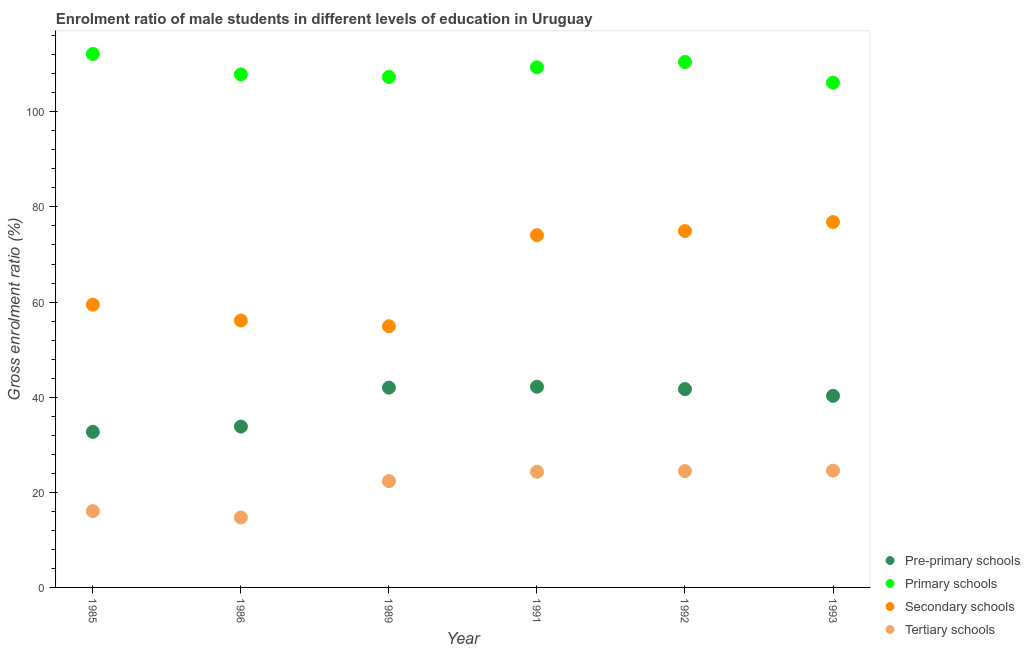What is the gross enrolment ratio(female) in secondary schools in 1991?
Provide a short and direct response. 74.06. Across all years, what is the maximum gross enrolment ratio(female) in pre-primary schools?
Keep it short and to the point. 42.2. Across all years, what is the minimum gross enrolment ratio(female) in tertiary schools?
Your answer should be very brief. 14.7. In which year was the gross enrolment ratio(female) in tertiary schools maximum?
Offer a very short reply. 1993. In which year was the gross enrolment ratio(female) in primary schools minimum?
Offer a very short reply. 1993. What is the total gross enrolment ratio(female) in pre-primary schools in the graph?
Ensure brevity in your answer.  232.72. What is the difference between the gross enrolment ratio(female) in secondary schools in 1989 and that in 1991?
Provide a short and direct response. -19.15. What is the difference between the gross enrolment ratio(female) in tertiary schools in 1993 and the gross enrolment ratio(female) in pre-primary schools in 1991?
Keep it short and to the point. -17.64. What is the average gross enrolment ratio(female) in primary schools per year?
Provide a succinct answer. 108.88. In the year 1992, what is the difference between the gross enrolment ratio(female) in pre-primary schools and gross enrolment ratio(female) in primary schools?
Provide a succinct answer. -68.77. What is the ratio of the gross enrolment ratio(female) in primary schools in 1985 to that in 1992?
Your response must be concise. 1.02. Is the gross enrolment ratio(female) in secondary schools in 1991 less than that in 1993?
Your answer should be very brief. Yes. What is the difference between the highest and the second highest gross enrolment ratio(female) in tertiary schools?
Make the answer very short. 0.1. What is the difference between the highest and the lowest gross enrolment ratio(female) in secondary schools?
Give a very brief answer. 21.92. In how many years, is the gross enrolment ratio(female) in secondary schools greater than the average gross enrolment ratio(female) in secondary schools taken over all years?
Offer a very short reply. 3. Is the sum of the gross enrolment ratio(female) in secondary schools in 1986 and 1991 greater than the maximum gross enrolment ratio(female) in tertiary schools across all years?
Your answer should be compact. Yes. Is the gross enrolment ratio(female) in pre-primary schools strictly greater than the gross enrolment ratio(female) in primary schools over the years?
Ensure brevity in your answer.  No. Is the gross enrolment ratio(female) in tertiary schools strictly less than the gross enrolment ratio(female) in primary schools over the years?
Your answer should be compact. Yes. How many dotlines are there?
Provide a short and direct response. 4. How many years are there in the graph?
Keep it short and to the point. 6. What is the difference between two consecutive major ticks on the Y-axis?
Provide a short and direct response. 20. Does the graph contain any zero values?
Keep it short and to the point. No. Where does the legend appear in the graph?
Your answer should be very brief. Bottom right. How many legend labels are there?
Your answer should be very brief. 4. What is the title of the graph?
Offer a terse response. Enrolment ratio of male students in different levels of education in Uruguay. Does "UNTA" appear as one of the legend labels in the graph?
Provide a succinct answer. No. What is the Gross enrolment ratio (%) in Pre-primary schools in 1985?
Offer a terse response. 32.71. What is the Gross enrolment ratio (%) of Primary schools in 1985?
Offer a very short reply. 112.15. What is the Gross enrolment ratio (%) in Secondary schools in 1985?
Keep it short and to the point. 59.44. What is the Gross enrolment ratio (%) of Tertiary schools in 1985?
Ensure brevity in your answer.  16.04. What is the Gross enrolment ratio (%) in Pre-primary schools in 1986?
Your answer should be compact. 33.83. What is the Gross enrolment ratio (%) of Primary schools in 1986?
Your response must be concise. 107.86. What is the Gross enrolment ratio (%) in Secondary schools in 1986?
Offer a very short reply. 56.11. What is the Gross enrolment ratio (%) of Tertiary schools in 1986?
Your response must be concise. 14.7. What is the Gross enrolment ratio (%) of Pre-primary schools in 1989?
Ensure brevity in your answer.  42.01. What is the Gross enrolment ratio (%) of Primary schools in 1989?
Give a very brief answer. 107.32. What is the Gross enrolment ratio (%) of Secondary schools in 1989?
Ensure brevity in your answer.  54.91. What is the Gross enrolment ratio (%) in Tertiary schools in 1989?
Give a very brief answer. 22.36. What is the Gross enrolment ratio (%) of Pre-primary schools in 1991?
Offer a terse response. 42.2. What is the Gross enrolment ratio (%) of Primary schools in 1991?
Keep it short and to the point. 109.35. What is the Gross enrolment ratio (%) in Secondary schools in 1991?
Offer a very short reply. 74.06. What is the Gross enrolment ratio (%) of Tertiary schools in 1991?
Provide a short and direct response. 24.33. What is the Gross enrolment ratio (%) of Pre-primary schools in 1992?
Provide a succinct answer. 41.7. What is the Gross enrolment ratio (%) of Primary schools in 1992?
Provide a succinct answer. 110.47. What is the Gross enrolment ratio (%) of Secondary schools in 1992?
Keep it short and to the point. 74.94. What is the Gross enrolment ratio (%) of Tertiary schools in 1992?
Give a very brief answer. 24.45. What is the Gross enrolment ratio (%) in Pre-primary schools in 1993?
Ensure brevity in your answer.  40.28. What is the Gross enrolment ratio (%) of Primary schools in 1993?
Give a very brief answer. 106.11. What is the Gross enrolment ratio (%) of Secondary schools in 1993?
Your answer should be compact. 76.83. What is the Gross enrolment ratio (%) in Tertiary schools in 1993?
Your answer should be compact. 24.55. Across all years, what is the maximum Gross enrolment ratio (%) in Pre-primary schools?
Your answer should be compact. 42.2. Across all years, what is the maximum Gross enrolment ratio (%) in Primary schools?
Offer a very short reply. 112.15. Across all years, what is the maximum Gross enrolment ratio (%) in Secondary schools?
Keep it short and to the point. 76.83. Across all years, what is the maximum Gross enrolment ratio (%) of Tertiary schools?
Offer a terse response. 24.55. Across all years, what is the minimum Gross enrolment ratio (%) of Pre-primary schools?
Give a very brief answer. 32.71. Across all years, what is the minimum Gross enrolment ratio (%) of Primary schools?
Ensure brevity in your answer.  106.11. Across all years, what is the minimum Gross enrolment ratio (%) in Secondary schools?
Offer a terse response. 54.91. Across all years, what is the minimum Gross enrolment ratio (%) in Tertiary schools?
Offer a very short reply. 14.7. What is the total Gross enrolment ratio (%) in Pre-primary schools in the graph?
Your answer should be very brief. 232.72. What is the total Gross enrolment ratio (%) of Primary schools in the graph?
Your response must be concise. 653.27. What is the total Gross enrolment ratio (%) of Secondary schools in the graph?
Make the answer very short. 396.29. What is the total Gross enrolment ratio (%) of Tertiary schools in the graph?
Make the answer very short. 126.43. What is the difference between the Gross enrolment ratio (%) in Pre-primary schools in 1985 and that in 1986?
Offer a terse response. -1.12. What is the difference between the Gross enrolment ratio (%) of Primary schools in 1985 and that in 1986?
Provide a short and direct response. 4.29. What is the difference between the Gross enrolment ratio (%) in Secondary schools in 1985 and that in 1986?
Ensure brevity in your answer.  3.33. What is the difference between the Gross enrolment ratio (%) in Tertiary schools in 1985 and that in 1986?
Provide a succinct answer. 1.34. What is the difference between the Gross enrolment ratio (%) of Pre-primary schools in 1985 and that in 1989?
Ensure brevity in your answer.  -9.3. What is the difference between the Gross enrolment ratio (%) of Primary schools in 1985 and that in 1989?
Your answer should be compact. 4.83. What is the difference between the Gross enrolment ratio (%) in Secondary schools in 1985 and that in 1989?
Offer a terse response. 4.53. What is the difference between the Gross enrolment ratio (%) of Tertiary schools in 1985 and that in 1989?
Ensure brevity in your answer.  -6.32. What is the difference between the Gross enrolment ratio (%) of Pre-primary schools in 1985 and that in 1991?
Your response must be concise. -9.49. What is the difference between the Gross enrolment ratio (%) in Primary schools in 1985 and that in 1991?
Your answer should be compact. 2.81. What is the difference between the Gross enrolment ratio (%) of Secondary schools in 1985 and that in 1991?
Ensure brevity in your answer.  -14.62. What is the difference between the Gross enrolment ratio (%) of Tertiary schools in 1985 and that in 1991?
Your response must be concise. -8.29. What is the difference between the Gross enrolment ratio (%) in Pre-primary schools in 1985 and that in 1992?
Ensure brevity in your answer.  -8.99. What is the difference between the Gross enrolment ratio (%) in Primary schools in 1985 and that in 1992?
Keep it short and to the point. 1.69. What is the difference between the Gross enrolment ratio (%) of Secondary schools in 1985 and that in 1992?
Your answer should be very brief. -15.49. What is the difference between the Gross enrolment ratio (%) of Tertiary schools in 1985 and that in 1992?
Ensure brevity in your answer.  -8.41. What is the difference between the Gross enrolment ratio (%) of Pre-primary schools in 1985 and that in 1993?
Make the answer very short. -7.57. What is the difference between the Gross enrolment ratio (%) in Primary schools in 1985 and that in 1993?
Offer a terse response. 6.04. What is the difference between the Gross enrolment ratio (%) of Secondary schools in 1985 and that in 1993?
Provide a succinct answer. -17.38. What is the difference between the Gross enrolment ratio (%) of Tertiary schools in 1985 and that in 1993?
Ensure brevity in your answer.  -8.51. What is the difference between the Gross enrolment ratio (%) in Pre-primary schools in 1986 and that in 1989?
Your answer should be compact. -8.18. What is the difference between the Gross enrolment ratio (%) of Primary schools in 1986 and that in 1989?
Offer a terse response. 0.54. What is the difference between the Gross enrolment ratio (%) of Secondary schools in 1986 and that in 1989?
Offer a very short reply. 1.2. What is the difference between the Gross enrolment ratio (%) of Tertiary schools in 1986 and that in 1989?
Your answer should be very brief. -7.66. What is the difference between the Gross enrolment ratio (%) of Pre-primary schools in 1986 and that in 1991?
Make the answer very short. -8.37. What is the difference between the Gross enrolment ratio (%) in Primary schools in 1986 and that in 1991?
Offer a very short reply. -1.48. What is the difference between the Gross enrolment ratio (%) of Secondary schools in 1986 and that in 1991?
Give a very brief answer. -17.95. What is the difference between the Gross enrolment ratio (%) in Tertiary schools in 1986 and that in 1991?
Your response must be concise. -9.63. What is the difference between the Gross enrolment ratio (%) of Pre-primary schools in 1986 and that in 1992?
Make the answer very short. -7.88. What is the difference between the Gross enrolment ratio (%) in Primary schools in 1986 and that in 1992?
Your response must be concise. -2.61. What is the difference between the Gross enrolment ratio (%) of Secondary schools in 1986 and that in 1992?
Provide a succinct answer. -18.82. What is the difference between the Gross enrolment ratio (%) in Tertiary schools in 1986 and that in 1992?
Your response must be concise. -9.76. What is the difference between the Gross enrolment ratio (%) of Pre-primary schools in 1986 and that in 1993?
Keep it short and to the point. -6.45. What is the difference between the Gross enrolment ratio (%) in Primary schools in 1986 and that in 1993?
Your answer should be very brief. 1.75. What is the difference between the Gross enrolment ratio (%) in Secondary schools in 1986 and that in 1993?
Offer a very short reply. -20.71. What is the difference between the Gross enrolment ratio (%) of Tertiary schools in 1986 and that in 1993?
Your answer should be very brief. -9.85. What is the difference between the Gross enrolment ratio (%) of Pre-primary schools in 1989 and that in 1991?
Your response must be concise. -0.19. What is the difference between the Gross enrolment ratio (%) in Primary schools in 1989 and that in 1991?
Your answer should be very brief. -2.02. What is the difference between the Gross enrolment ratio (%) in Secondary schools in 1989 and that in 1991?
Keep it short and to the point. -19.15. What is the difference between the Gross enrolment ratio (%) of Tertiary schools in 1989 and that in 1991?
Offer a terse response. -1.97. What is the difference between the Gross enrolment ratio (%) in Pre-primary schools in 1989 and that in 1992?
Your response must be concise. 0.31. What is the difference between the Gross enrolment ratio (%) in Primary schools in 1989 and that in 1992?
Ensure brevity in your answer.  -3.14. What is the difference between the Gross enrolment ratio (%) of Secondary schools in 1989 and that in 1992?
Provide a short and direct response. -20.02. What is the difference between the Gross enrolment ratio (%) in Tertiary schools in 1989 and that in 1992?
Give a very brief answer. -2.1. What is the difference between the Gross enrolment ratio (%) of Pre-primary schools in 1989 and that in 1993?
Provide a succinct answer. 1.73. What is the difference between the Gross enrolment ratio (%) in Primary schools in 1989 and that in 1993?
Your response must be concise. 1.21. What is the difference between the Gross enrolment ratio (%) in Secondary schools in 1989 and that in 1993?
Ensure brevity in your answer.  -21.92. What is the difference between the Gross enrolment ratio (%) of Tertiary schools in 1989 and that in 1993?
Offer a very short reply. -2.2. What is the difference between the Gross enrolment ratio (%) of Pre-primary schools in 1991 and that in 1992?
Provide a succinct answer. 0.49. What is the difference between the Gross enrolment ratio (%) in Primary schools in 1991 and that in 1992?
Offer a terse response. -1.12. What is the difference between the Gross enrolment ratio (%) in Secondary schools in 1991 and that in 1992?
Make the answer very short. -0.88. What is the difference between the Gross enrolment ratio (%) in Tertiary schools in 1991 and that in 1992?
Offer a very short reply. -0.13. What is the difference between the Gross enrolment ratio (%) of Pre-primary schools in 1991 and that in 1993?
Give a very brief answer. 1.92. What is the difference between the Gross enrolment ratio (%) in Primary schools in 1991 and that in 1993?
Provide a short and direct response. 3.23. What is the difference between the Gross enrolment ratio (%) of Secondary schools in 1991 and that in 1993?
Ensure brevity in your answer.  -2.77. What is the difference between the Gross enrolment ratio (%) of Tertiary schools in 1991 and that in 1993?
Your answer should be compact. -0.22. What is the difference between the Gross enrolment ratio (%) in Pre-primary schools in 1992 and that in 1993?
Offer a terse response. 1.42. What is the difference between the Gross enrolment ratio (%) in Primary schools in 1992 and that in 1993?
Give a very brief answer. 4.36. What is the difference between the Gross enrolment ratio (%) of Secondary schools in 1992 and that in 1993?
Keep it short and to the point. -1.89. What is the difference between the Gross enrolment ratio (%) of Tertiary schools in 1992 and that in 1993?
Offer a very short reply. -0.1. What is the difference between the Gross enrolment ratio (%) of Pre-primary schools in 1985 and the Gross enrolment ratio (%) of Primary schools in 1986?
Your response must be concise. -75.15. What is the difference between the Gross enrolment ratio (%) in Pre-primary schools in 1985 and the Gross enrolment ratio (%) in Secondary schools in 1986?
Offer a terse response. -23.4. What is the difference between the Gross enrolment ratio (%) in Pre-primary schools in 1985 and the Gross enrolment ratio (%) in Tertiary schools in 1986?
Offer a terse response. 18.01. What is the difference between the Gross enrolment ratio (%) of Primary schools in 1985 and the Gross enrolment ratio (%) of Secondary schools in 1986?
Your answer should be compact. 56.04. What is the difference between the Gross enrolment ratio (%) in Primary schools in 1985 and the Gross enrolment ratio (%) in Tertiary schools in 1986?
Offer a very short reply. 97.45. What is the difference between the Gross enrolment ratio (%) in Secondary schools in 1985 and the Gross enrolment ratio (%) in Tertiary schools in 1986?
Your response must be concise. 44.74. What is the difference between the Gross enrolment ratio (%) in Pre-primary schools in 1985 and the Gross enrolment ratio (%) in Primary schools in 1989?
Your answer should be very brief. -74.61. What is the difference between the Gross enrolment ratio (%) of Pre-primary schools in 1985 and the Gross enrolment ratio (%) of Secondary schools in 1989?
Ensure brevity in your answer.  -22.2. What is the difference between the Gross enrolment ratio (%) of Pre-primary schools in 1985 and the Gross enrolment ratio (%) of Tertiary schools in 1989?
Your answer should be very brief. 10.35. What is the difference between the Gross enrolment ratio (%) in Primary schools in 1985 and the Gross enrolment ratio (%) in Secondary schools in 1989?
Keep it short and to the point. 57.24. What is the difference between the Gross enrolment ratio (%) of Primary schools in 1985 and the Gross enrolment ratio (%) of Tertiary schools in 1989?
Provide a succinct answer. 89.8. What is the difference between the Gross enrolment ratio (%) of Secondary schools in 1985 and the Gross enrolment ratio (%) of Tertiary schools in 1989?
Provide a succinct answer. 37.09. What is the difference between the Gross enrolment ratio (%) of Pre-primary schools in 1985 and the Gross enrolment ratio (%) of Primary schools in 1991?
Make the answer very short. -76.64. What is the difference between the Gross enrolment ratio (%) in Pre-primary schools in 1985 and the Gross enrolment ratio (%) in Secondary schools in 1991?
Your response must be concise. -41.35. What is the difference between the Gross enrolment ratio (%) in Pre-primary schools in 1985 and the Gross enrolment ratio (%) in Tertiary schools in 1991?
Offer a terse response. 8.38. What is the difference between the Gross enrolment ratio (%) of Primary schools in 1985 and the Gross enrolment ratio (%) of Secondary schools in 1991?
Give a very brief answer. 38.09. What is the difference between the Gross enrolment ratio (%) of Primary schools in 1985 and the Gross enrolment ratio (%) of Tertiary schools in 1991?
Offer a terse response. 87.82. What is the difference between the Gross enrolment ratio (%) in Secondary schools in 1985 and the Gross enrolment ratio (%) in Tertiary schools in 1991?
Make the answer very short. 35.11. What is the difference between the Gross enrolment ratio (%) of Pre-primary schools in 1985 and the Gross enrolment ratio (%) of Primary schools in 1992?
Keep it short and to the point. -77.76. What is the difference between the Gross enrolment ratio (%) in Pre-primary schools in 1985 and the Gross enrolment ratio (%) in Secondary schools in 1992?
Offer a terse response. -42.23. What is the difference between the Gross enrolment ratio (%) of Pre-primary schools in 1985 and the Gross enrolment ratio (%) of Tertiary schools in 1992?
Your answer should be compact. 8.25. What is the difference between the Gross enrolment ratio (%) of Primary schools in 1985 and the Gross enrolment ratio (%) of Secondary schools in 1992?
Provide a succinct answer. 37.22. What is the difference between the Gross enrolment ratio (%) of Primary schools in 1985 and the Gross enrolment ratio (%) of Tertiary schools in 1992?
Give a very brief answer. 87.7. What is the difference between the Gross enrolment ratio (%) in Secondary schools in 1985 and the Gross enrolment ratio (%) in Tertiary schools in 1992?
Your response must be concise. 34.99. What is the difference between the Gross enrolment ratio (%) in Pre-primary schools in 1985 and the Gross enrolment ratio (%) in Primary schools in 1993?
Make the answer very short. -73.4. What is the difference between the Gross enrolment ratio (%) of Pre-primary schools in 1985 and the Gross enrolment ratio (%) of Secondary schools in 1993?
Make the answer very short. -44.12. What is the difference between the Gross enrolment ratio (%) in Pre-primary schools in 1985 and the Gross enrolment ratio (%) in Tertiary schools in 1993?
Provide a short and direct response. 8.16. What is the difference between the Gross enrolment ratio (%) in Primary schools in 1985 and the Gross enrolment ratio (%) in Secondary schools in 1993?
Make the answer very short. 35.33. What is the difference between the Gross enrolment ratio (%) in Primary schools in 1985 and the Gross enrolment ratio (%) in Tertiary schools in 1993?
Ensure brevity in your answer.  87.6. What is the difference between the Gross enrolment ratio (%) of Secondary schools in 1985 and the Gross enrolment ratio (%) of Tertiary schools in 1993?
Give a very brief answer. 34.89. What is the difference between the Gross enrolment ratio (%) in Pre-primary schools in 1986 and the Gross enrolment ratio (%) in Primary schools in 1989?
Keep it short and to the point. -73.5. What is the difference between the Gross enrolment ratio (%) of Pre-primary schools in 1986 and the Gross enrolment ratio (%) of Secondary schools in 1989?
Your answer should be compact. -21.09. What is the difference between the Gross enrolment ratio (%) in Pre-primary schools in 1986 and the Gross enrolment ratio (%) in Tertiary schools in 1989?
Provide a succinct answer. 11.47. What is the difference between the Gross enrolment ratio (%) in Primary schools in 1986 and the Gross enrolment ratio (%) in Secondary schools in 1989?
Provide a succinct answer. 52.95. What is the difference between the Gross enrolment ratio (%) in Primary schools in 1986 and the Gross enrolment ratio (%) in Tertiary schools in 1989?
Offer a very short reply. 85.51. What is the difference between the Gross enrolment ratio (%) in Secondary schools in 1986 and the Gross enrolment ratio (%) in Tertiary schools in 1989?
Your answer should be very brief. 33.76. What is the difference between the Gross enrolment ratio (%) of Pre-primary schools in 1986 and the Gross enrolment ratio (%) of Primary schools in 1991?
Ensure brevity in your answer.  -75.52. What is the difference between the Gross enrolment ratio (%) of Pre-primary schools in 1986 and the Gross enrolment ratio (%) of Secondary schools in 1991?
Make the answer very short. -40.23. What is the difference between the Gross enrolment ratio (%) in Pre-primary schools in 1986 and the Gross enrolment ratio (%) in Tertiary schools in 1991?
Give a very brief answer. 9.5. What is the difference between the Gross enrolment ratio (%) in Primary schools in 1986 and the Gross enrolment ratio (%) in Secondary schools in 1991?
Your response must be concise. 33.8. What is the difference between the Gross enrolment ratio (%) of Primary schools in 1986 and the Gross enrolment ratio (%) of Tertiary schools in 1991?
Offer a very short reply. 83.53. What is the difference between the Gross enrolment ratio (%) of Secondary schools in 1986 and the Gross enrolment ratio (%) of Tertiary schools in 1991?
Offer a terse response. 31.78. What is the difference between the Gross enrolment ratio (%) of Pre-primary schools in 1986 and the Gross enrolment ratio (%) of Primary schools in 1992?
Provide a succinct answer. -76.64. What is the difference between the Gross enrolment ratio (%) in Pre-primary schools in 1986 and the Gross enrolment ratio (%) in Secondary schools in 1992?
Offer a terse response. -41.11. What is the difference between the Gross enrolment ratio (%) in Pre-primary schools in 1986 and the Gross enrolment ratio (%) in Tertiary schools in 1992?
Provide a short and direct response. 9.37. What is the difference between the Gross enrolment ratio (%) of Primary schools in 1986 and the Gross enrolment ratio (%) of Secondary schools in 1992?
Give a very brief answer. 32.93. What is the difference between the Gross enrolment ratio (%) in Primary schools in 1986 and the Gross enrolment ratio (%) in Tertiary schools in 1992?
Ensure brevity in your answer.  83.41. What is the difference between the Gross enrolment ratio (%) in Secondary schools in 1986 and the Gross enrolment ratio (%) in Tertiary schools in 1992?
Provide a short and direct response. 31.66. What is the difference between the Gross enrolment ratio (%) in Pre-primary schools in 1986 and the Gross enrolment ratio (%) in Primary schools in 1993?
Your response must be concise. -72.29. What is the difference between the Gross enrolment ratio (%) of Pre-primary schools in 1986 and the Gross enrolment ratio (%) of Secondary schools in 1993?
Your answer should be very brief. -43. What is the difference between the Gross enrolment ratio (%) in Pre-primary schools in 1986 and the Gross enrolment ratio (%) in Tertiary schools in 1993?
Offer a very short reply. 9.27. What is the difference between the Gross enrolment ratio (%) in Primary schools in 1986 and the Gross enrolment ratio (%) in Secondary schools in 1993?
Your response must be concise. 31.04. What is the difference between the Gross enrolment ratio (%) of Primary schools in 1986 and the Gross enrolment ratio (%) of Tertiary schools in 1993?
Offer a terse response. 83.31. What is the difference between the Gross enrolment ratio (%) in Secondary schools in 1986 and the Gross enrolment ratio (%) in Tertiary schools in 1993?
Provide a short and direct response. 31.56. What is the difference between the Gross enrolment ratio (%) of Pre-primary schools in 1989 and the Gross enrolment ratio (%) of Primary schools in 1991?
Offer a terse response. -67.34. What is the difference between the Gross enrolment ratio (%) of Pre-primary schools in 1989 and the Gross enrolment ratio (%) of Secondary schools in 1991?
Offer a terse response. -32.05. What is the difference between the Gross enrolment ratio (%) in Pre-primary schools in 1989 and the Gross enrolment ratio (%) in Tertiary schools in 1991?
Give a very brief answer. 17.68. What is the difference between the Gross enrolment ratio (%) of Primary schools in 1989 and the Gross enrolment ratio (%) of Secondary schools in 1991?
Keep it short and to the point. 33.26. What is the difference between the Gross enrolment ratio (%) of Primary schools in 1989 and the Gross enrolment ratio (%) of Tertiary schools in 1991?
Offer a very short reply. 82.99. What is the difference between the Gross enrolment ratio (%) in Secondary schools in 1989 and the Gross enrolment ratio (%) in Tertiary schools in 1991?
Make the answer very short. 30.58. What is the difference between the Gross enrolment ratio (%) in Pre-primary schools in 1989 and the Gross enrolment ratio (%) in Primary schools in 1992?
Give a very brief answer. -68.46. What is the difference between the Gross enrolment ratio (%) in Pre-primary schools in 1989 and the Gross enrolment ratio (%) in Secondary schools in 1992?
Provide a succinct answer. -32.93. What is the difference between the Gross enrolment ratio (%) in Pre-primary schools in 1989 and the Gross enrolment ratio (%) in Tertiary schools in 1992?
Your answer should be very brief. 17.55. What is the difference between the Gross enrolment ratio (%) of Primary schools in 1989 and the Gross enrolment ratio (%) of Secondary schools in 1992?
Provide a short and direct response. 32.39. What is the difference between the Gross enrolment ratio (%) in Primary schools in 1989 and the Gross enrolment ratio (%) in Tertiary schools in 1992?
Ensure brevity in your answer.  82.87. What is the difference between the Gross enrolment ratio (%) of Secondary schools in 1989 and the Gross enrolment ratio (%) of Tertiary schools in 1992?
Make the answer very short. 30.46. What is the difference between the Gross enrolment ratio (%) of Pre-primary schools in 1989 and the Gross enrolment ratio (%) of Primary schools in 1993?
Offer a terse response. -64.11. What is the difference between the Gross enrolment ratio (%) of Pre-primary schools in 1989 and the Gross enrolment ratio (%) of Secondary schools in 1993?
Make the answer very short. -34.82. What is the difference between the Gross enrolment ratio (%) of Pre-primary schools in 1989 and the Gross enrolment ratio (%) of Tertiary schools in 1993?
Your answer should be very brief. 17.46. What is the difference between the Gross enrolment ratio (%) of Primary schools in 1989 and the Gross enrolment ratio (%) of Secondary schools in 1993?
Give a very brief answer. 30.5. What is the difference between the Gross enrolment ratio (%) of Primary schools in 1989 and the Gross enrolment ratio (%) of Tertiary schools in 1993?
Make the answer very short. 82.77. What is the difference between the Gross enrolment ratio (%) in Secondary schools in 1989 and the Gross enrolment ratio (%) in Tertiary schools in 1993?
Offer a terse response. 30.36. What is the difference between the Gross enrolment ratio (%) in Pre-primary schools in 1991 and the Gross enrolment ratio (%) in Primary schools in 1992?
Keep it short and to the point. -68.27. What is the difference between the Gross enrolment ratio (%) of Pre-primary schools in 1991 and the Gross enrolment ratio (%) of Secondary schools in 1992?
Your response must be concise. -32.74. What is the difference between the Gross enrolment ratio (%) of Pre-primary schools in 1991 and the Gross enrolment ratio (%) of Tertiary schools in 1992?
Offer a very short reply. 17.74. What is the difference between the Gross enrolment ratio (%) in Primary schools in 1991 and the Gross enrolment ratio (%) in Secondary schools in 1992?
Your answer should be compact. 34.41. What is the difference between the Gross enrolment ratio (%) of Primary schools in 1991 and the Gross enrolment ratio (%) of Tertiary schools in 1992?
Your answer should be compact. 84.89. What is the difference between the Gross enrolment ratio (%) in Secondary schools in 1991 and the Gross enrolment ratio (%) in Tertiary schools in 1992?
Your answer should be compact. 49.6. What is the difference between the Gross enrolment ratio (%) in Pre-primary schools in 1991 and the Gross enrolment ratio (%) in Primary schools in 1993?
Keep it short and to the point. -63.92. What is the difference between the Gross enrolment ratio (%) in Pre-primary schools in 1991 and the Gross enrolment ratio (%) in Secondary schools in 1993?
Offer a terse response. -34.63. What is the difference between the Gross enrolment ratio (%) of Pre-primary schools in 1991 and the Gross enrolment ratio (%) of Tertiary schools in 1993?
Your response must be concise. 17.64. What is the difference between the Gross enrolment ratio (%) in Primary schools in 1991 and the Gross enrolment ratio (%) in Secondary schools in 1993?
Offer a terse response. 32.52. What is the difference between the Gross enrolment ratio (%) in Primary schools in 1991 and the Gross enrolment ratio (%) in Tertiary schools in 1993?
Offer a terse response. 84.79. What is the difference between the Gross enrolment ratio (%) of Secondary schools in 1991 and the Gross enrolment ratio (%) of Tertiary schools in 1993?
Ensure brevity in your answer.  49.51. What is the difference between the Gross enrolment ratio (%) of Pre-primary schools in 1992 and the Gross enrolment ratio (%) of Primary schools in 1993?
Offer a very short reply. -64.41. What is the difference between the Gross enrolment ratio (%) in Pre-primary schools in 1992 and the Gross enrolment ratio (%) in Secondary schools in 1993?
Provide a succinct answer. -35.12. What is the difference between the Gross enrolment ratio (%) of Pre-primary schools in 1992 and the Gross enrolment ratio (%) of Tertiary schools in 1993?
Offer a very short reply. 17.15. What is the difference between the Gross enrolment ratio (%) of Primary schools in 1992 and the Gross enrolment ratio (%) of Secondary schools in 1993?
Give a very brief answer. 33.64. What is the difference between the Gross enrolment ratio (%) in Primary schools in 1992 and the Gross enrolment ratio (%) in Tertiary schools in 1993?
Offer a very short reply. 85.92. What is the difference between the Gross enrolment ratio (%) of Secondary schools in 1992 and the Gross enrolment ratio (%) of Tertiary schools in 1993?
Your response must be concise. 50.38. What is the average Gross enrolment ratio (%) of Pre-primary schools per year?
Keep it short and to the point. 38.79. What is the average Gross enrolment ratio (%) of Primary schools per year?
Offer a very short reply. 108.88. What is the average Gross enrolment ratio (%) of Secondary schools per year?
Your response must be concise. 66.05. What is the average Gross enrolment ratio (%) of Tertiary schools per year?
Your response must be concise. 21.07. In the year 1985, what is the difference between the Gross enrolment ratio (%) of Pre-primary schools and Gross enrolment ratio (%) of Primary schools?
Offer a very short reply. -79.44. In the year 1985, what is the difference between the Gross enrolment ratio (%) of Pre-primary schools and Gross enrolment ratio (%) of Secondary schools?
Ensure brevity in your answer.  -26.73. In the year 1985, what is the difference between the Gross enrolment ratio (%) of Pre-primary schools and Gross enrolment ratio (%) of Tertiary schools?
Provide a succinct answer. 16.67. In the year 1985, what is the difference between the Gross enrolment ratio (%) of Primary schools and Gross enrolment ratio (%) of Secondary schools?
Make the answer very short. 52.71. In the year 1985, what is the difference between the Gross enrolment ratio (%) of Primary schools and Gross enrolment ratio (%) of Tertiary schools?
Offer a terse response. 96.11. In the year 1985, what is the difference between the Gross enrolment ratio (%) in Secondary schools and Gross enrolment ratio (%) in Tertiary schools?
Offer a terse response. 43.4. In the year 1986, what is the difference between the Gross enrolment ratio (%) of Pre-primary schools and Gross enrolment ratio (%) of Primary schools?
Your response must be concise. -74.04. In the year 1986, what is the difference between the Gross enrolment ratio (%) of Pre-primary schools and Gross enrolment ratio (%) of Secondary schools?
Provide a short and direct response. -22.29. In the year 1986, what is the difference between the Gross enrolment ratio (%) of Pre-primary schools and Gross enrolment ratio (%) of Tertiary schools?
Offer a terse response. 19.13. In the year 1986, what is the difference between the Gross enrolment ratio (%) in Primary schools and Gross enrolment ratio (%) in Secondary schools?
Ensure brevity in your answer.  51.75. In the year 1986, what is the difference between the Gross enrolment ratio (%) of Primary schools and Gross enrolment ratio (%) of Tertiary schools?
Give a very brief answer. 93.16. In the year 1986, what is the difference between the Gross enrolment ratio (%) of Secondary schools and Gross enrolment ratio (%) of Tertiary schools?
Your answer should be very brief. 41.41. In the year 1989, what is the difference between the Gross enrolment ratio (%) in Pre-primary schools and Gross enrolment ratio (%) in Primary schools?
Ensure brevity in your answer.  -65.32. In the year 1989, what is the difference between the Gross enrolment ratio (%) in Pre-primary schools and Gross enrolment ratio (%) in Secondary schools?
Give a very brief answer. -12.9. In the year 1989, what is the difference between the Gross enrolment ratio (%) of Pre-primary schools and Gross enrolment ratio (%) of Tertiary schools?
Ensure brevity in your answer.  19.65. In the year 1989, what is the difference between the Gross enrolment ratio (%) of Primary schools and Gross enrolment ratio (%) of Secondary schools?
Provide a succinct answer. 52.41. In the year 1989, what is the difference between the Gross enrolment ratio (%) in Primary schools and Gross enrolment ratio (%) in Tertiary schools?
Ensure brevity in your answer.  84.97. In the year 1989, what is the difference between the Gross enrolment ratio (%) in Secondary schools and Gross enrolment ratio (%) in Tertiary schools?
Ensure brevity in your answer.  32.55. In the year 1991, what is the difference between the Gross enrolment ratio (%) of Pre-primary schools and Gross enrolment ratio (%) of Primary schools?
Ensure brevity in your answer.  -67.15. In the year 1991, what is the difference between the Gross enrolment ratio (%) in Pre-primary schools and Gross enrolment ratio (%) in Secondary schools?
Your answer should be compact. -31.86. In the year 1991, what is the difference between the Gross enrolment ratio (%) of Pre-primary schools and Gross enrolment ratio (%) of Tertiary schools?
Ensure brevity in your answer.  17.87. In the year 1991, what is the difference between the Gross enrolment ratio (%) in Primary schools and Gross enrolment ratio (%) in Secondary schools?
Offer a very short reply. 35.29. In the year 1991, what is the difference between the Gross enrolment ratio (%) of Primary schools and Gross enrolment ratio (%) of Tertiary schools?
Provide a succinct answer. 85.02. In the year 1991, what is the difference between the Gross enrolment ratio (%) of Secondary schools and Gross enrolment ratio (%) of Tertiary schools?
Offer a very short reply. 49.73. In the year 1992, what is the difference between the Gross enrolment ratio (%) in Pre-primary schools and Gross enrolment ratio (%) in Primary schools?
Your response must be concise. -68.77. In the year 1992, what is the difference between the Gross enrolment ratio (%) of Pre-primary schools and Gross enrolment ratio (%) of Secondary schools?
Your response must be concise. -33.23. In the year 1992, what is the difference between the Gross enrolment ratio (%) of Pre-primary schools and Gross enrolment ratio (%) of Tertiary schools?
Provide a succinct answer. 17.25. In the year 1992, what is the difference between the Gross enrolment ratio (%) in Primary schools and Gross enrolment ratio (%) in Secondary schools?
Make the answer very short. 35.53. In the year 1992, what is the difference between the Gross enrolment ratio (%) of Primary schools and Gross enrolment ratio (%) of Tertiary schools?
Make the answer very short. 86.01. In the year 1992, what is the difference between the Gross enrolment ratio (%) in Secondary schools and Gross enrolment ratio (%) in Tertiary schools?
Keep it short and to the point. 50.48. In the year 1993, what is the difference between the Gross enrolment ratio (%) of Pre-primary schools and Gross enrolment ratio (%) of Primary schools?
Your answer should be very brief. -65.83. In the year 1993, what is the difference between the Gross enrolment ratio (%) in Pre-primary schools and Gross enrolment ratio (%) in Secondary schools?
Offer a very short reply. -36.55. In the year 1993, what is the difference between the Gross enrolment ratio (%) in Pre-primary schools and Gross enrolment ratio (%) in Tertiary schools?
Provide a succinct answer. 15.73. In the year 1993, what is the difference between the Gross enrolment ratio (%) in Primary schools and Gross enrolment ratio (%) in Secondary schools?
Keep it short and to the point. 29.29. In the year 1993, what is the difference between the Gross enrolment ratio (%) in Primary schools and Gross enrolment ratio (%) in Tertiary schools?
Your answer should be very brief. 81.56. In the year 1993, what is the difference between the Gross enrolment ratio (%) in Secondary schools and Gross enrolment ratio (%) in Tertiary schools?
Offer a terse response. 52.27. What is the ratio of the Gross enrolment ratio (%) in Primary schools in 1985 to that in 1986?
Your answer should be very brief. 1.04. What is the ratio of the Gross enrolment ratio (%) in Secondary schools in 1985 to that in 1986?
Offer a terse response. 1.06. What is the ratio of the Gross enrolment ratio (%) in Tertiary schools in 1985 to that in 1986?
Ensure brevity in your answer.  1.09. What is the ratio of the Gross enrolment ratio (%) of Pre-primary schools in 1985 to that in 1989?
Ensure brevity in your answer.  0.78. What is the ratio of the Gross enrolment ratio (%) in Primary schools in 1985 to that in 1989?
Provide a succinct answer. 1.04. What is the ratio of the Gross enrolment ratio (%) of Secondary schools in 1985 to that in 1989?
Your response must be concise. 1.08. What is the ratio of the Gross enrolment ratio (%) of Tertiary schools in 1985 to that in 1989?
Keep it short and to the point. 0.72. What is the ratio of the Gross enrolment ratio (%) in Pre-primary schools in 1985 to that in 1991?
Give a very brief answer. 0.78. What is the ratio of the Gross enrolment ratio (%) in Primary schools in 1985 to that in 1991?
Provide a short and direct response. 1.03. What is the ratio of the Gross enrolment ratio (%) in Secondary schools in 1985 to that in 1991?
Offer a very short reply. 0.8. What is the ratio of the Gross enrolment ratio (%) of Tertiary schools in 1985 to that in 1991?
Make the answer very short. 0.66. What is the ratio of the Gross enrolment ratio (%) in Pre-primary schools in 1985 to that in 1992?
Your answer should be compact. 0.78. What is the ratio of the Gross enrolment ratio (%) in Primary schools in 1985 to that in 1992?
Your answer should be compact. 1.02. What is the ratio of the Gross enrolment ratio (%) in Secondary schools in 1985 to that in 1992?
Your answer should be compact. 0.79. What is the ratio of the Gross enrolment ratio (%) of Tertiary schools in 1985 to that in 1992?
Your response must be concise. 0.66. What is the ratio of the Gross enrolment ratio (%) in Pre-primary schools in 1985 to that in 1993?
Offer a terse response. 0.81. What is the ratio of the Gross enrolment ratio (%) of Primary schools in 1985 to that in 1993?
Provide a short and direct response. 1.06. What is the ratio of the Gross enrolment ratio (%) in Secondary schools in 1985 to that in 1993?
Give a very brief answer. 0.77. What is the ratio of the Gross enrolment ratio (%) of Tertiary schools in 1985 to that in 1993?
Keep it short and to the point. 0.65. What is the ratio of the Gross enrolment ratio (%) in Pre-primary schools in 1986 to that in 1989?
Provide a short and direct response. 0.81. What is the ratio of the Gross enrolment ratio (%) in Primary schools in 1986 to that in 1989?
Offer a terse response. 1. What is the ratio of the Gross enrolment ratio (%) in Secondary schools in 1986 to that in 1989?
Provide a succinct answer. 1.02. What is the ratio of the Gross enrolment ratio (%) in Tertiary schools in 1986 to that in 1989?
Keep it short and to the point. 0.66. What is the ratio of the Gross enrolment ratio (%) of Pre-primary schools in 1986 to that in 1991?
Your answer should be very brief. 0.8. What is the ratio of the Gross enrolment ratio (%) in Primary schools in 1986 to that in 1991?
Make the answer very short. 0.99. What is the ratio of the Gross enrolment ratio (%) of Secondary schools in 1986 to that in 1991?
Offer a very short reply. 0.76. What is the ratio of the Gross enrolment ratio (%) in Tertiary schools in 1986 to that in 1991?
Your answer should be compact. 0.6. What is the ratio of the Gross enrolment ratio (%) in Pre-primary schools in 1986 to that in 1992?
Offer a terse response. 0.81. What is the ratio of the Gross enrolment ratio (%) in Primary schools in 1986 to that in 1992?
Make the answer very short. 0.98. What is the ratio of the Gross enrolment ratio (%) in Secondary schools in 1986 to that in 1992?
Keep it short and to the point. 0.75. What is the ratio of the Gross enrolment ratio (%) in Tertiary schools in 1986 to that in 1992?
Ensure brevity in your answer.  0.6. What is the ratio of the Gross enrolment ratio (%) in Pre-primary schools in 1986 to that in 1993?
Make the answer very short. 0.84. What is the ratio of the Gross enrolment ratio (%) in Primary schools in 1986 to that in 1993?
Your response must be concise. 1.02. What is the ratio of the Gross enrolment ratio (%) in Secondary schools in 1986 to that in 1993?
Make the answer very short. 0.73. What is the ratio of the Gross enrolment ratio (%) of Tertiary schools in 1986 to that in 1993?
Give a very brief answer. 0.6. What is the ratio of the Gross enrolment ratio (%) in Primary schools in 1989 to that in 1991?
Your answer should be compact. 0.98. What is the ratio of the Gross enrolment ratio (%) of Secondary schools in 1989 to that in 1991?
Your answer should be compact. 0.74. What is the ratio of the Gross enrolment ratio (%) in Tertiary schools in 1989 to that in 1991?
Your response must be concise. 0.92. What is the ratio of the Gross enrolment ratio (%) of Pre-primary schools in 1989 to that in 1992?
Ensure brevity in your answer.  1.01. What is the ratio of the Gross enrolment ratio (%) in Primary schools in 1989 to that in 1992?
Make the answer very short. 0.97. What is the ratio of the Gross enrolment ratio (%) of Secondary schools in 1989 to that in 1992?
Your answer should be very brief. 0.73. What is the ratio of the Gross enrolment ratio (%) of Tertiary schools in 1989 to that in 1992?
Offer a very short reply. 0.91. What is the ratio of the Gross enrolment ratio (%) of Pre-primary schools in 1989 to that in 1993?
Offer a terse response. 1.04. What is the ratio of the Gross enrolment ratio (%) in Primary schools in 1989 to that in 1993?
Provide a short and direct response. 1.01. What is the ratio of the Gross enrolment ratio (%) of Secondary schools in 1989 to that in 1993?
Ensure brevity in your answer.  0.71. What is the ratio of the Gross enrolment ratio (%) of Tertiary schools in 1989 to that in 1993?
Your answer should be very brief. 0.91. What is the ratio of the Gross enrolment ratio (%) of Pre-primary schools in 1991 to that in 1992?
Your response must be concise. 1.01. What is the ratio of the Gross enrolment ratio (%) in Secondary schools in 1991 to that in 1992?
Your response must be concise. 0.99. What is the ratio of the Gross enrolment ratio (%) in Pre-primary schools in 1991 to that in 1993?
Offer a very short reply. 1.05. What is the ratio of the Gross enrolment ratio (%) of Primary schools in 1991 to that in 1993?
Provide a short and direct response. 1.03. What is the ratio of the Gross enrolment ratio (%) in Tertiary schools in 1991 to that in 1993?
Ensure brevity in your answer.  0.99. What is the ratio of the Gross enrolment ratio (%) of Pre-primary schools in 1992 to that in 1993?
Keep it short and to the point. 1.04. What is the ratio of the Gross enrolment ratio (%) in Primary schools in 1992 to that in 1993?
Give a very brief answer. 1.04. What is the ratio of the Gross enrolment ratio (%) in Secondary schools in 1992 to that in 1993?
Offer a terse response. 0.98. What is the difference between the highest and the second highest Gross enrolment ratio (%) of Pre-primary schools?
Offer a very short reply. 0.19. What is the difference between the highest and the second highest Gross enrolment ratio (%) of Primary schools?
Your answer should be compact. 1.69. What is the difference between the highest and the second highest Gross enrolment ratio (%) of Secondary schools?
Provide a short and direct response. 1.89. What is the difference between the highest and the second highest Gross enrolment ratio (%) in Tertiary schools?
Give a very brief answer. 0.1. What is the difference between the highest and the lowest Gross enrolment ratio (%) of Pre-primary schools?
Offer a terse response. 9.49. What is the difference between the highest and the lowest Gross enrolment ratio (%) in Primary schools?
Your answer should be very brief. 6.04. What is the difference between the highest and the lowest Gross enrolment ratio (%) of Secondary schools?
Make the answer very short. 21.92. What is the difference between the highest and the lowest Gross enrolment ratio (%) in Tertiary schools?
Make the answer very short. 9.85. 